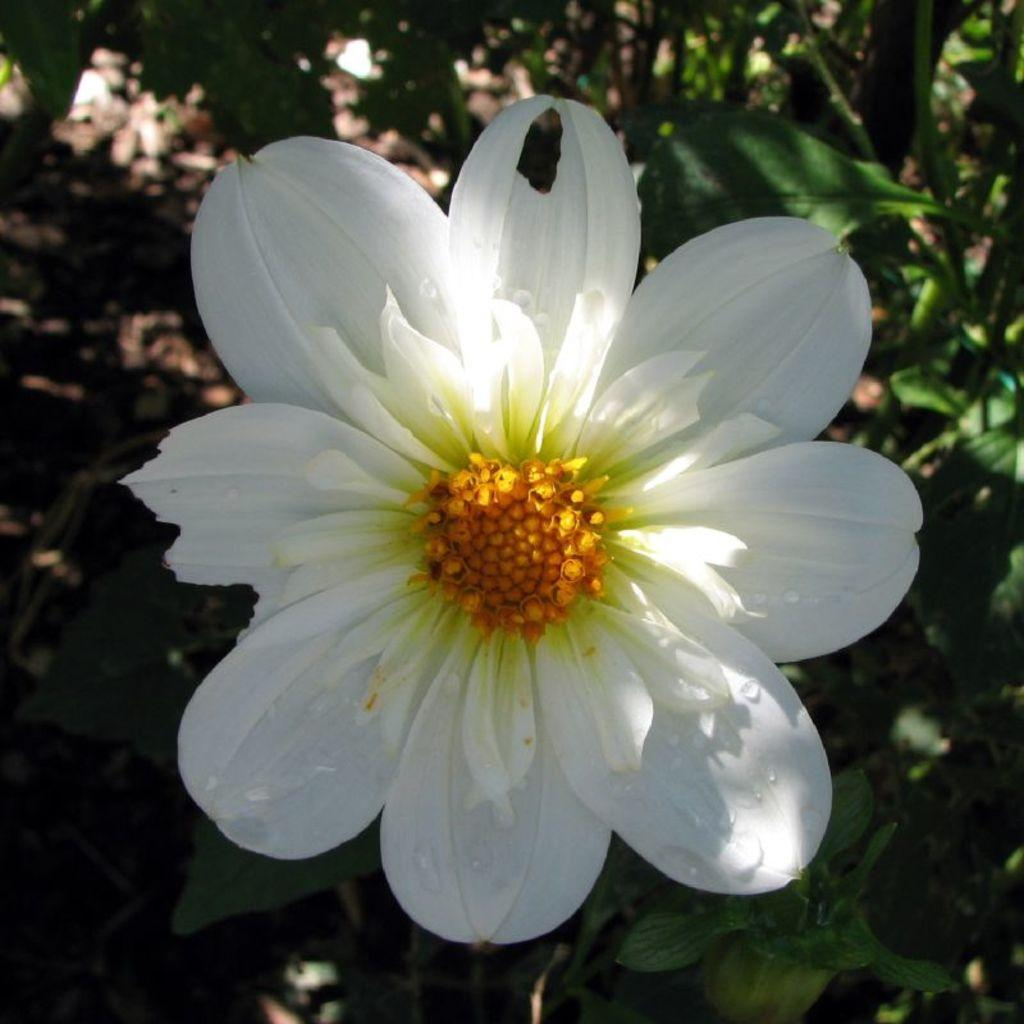What is the main subject of the image? There is a flower in the image. What can be seen in the background of the image? There are leaves in the background of the image. What type of riddle is the flower solving in the image? There is no riddle present in the image, and the flower is not solving any riddle. 